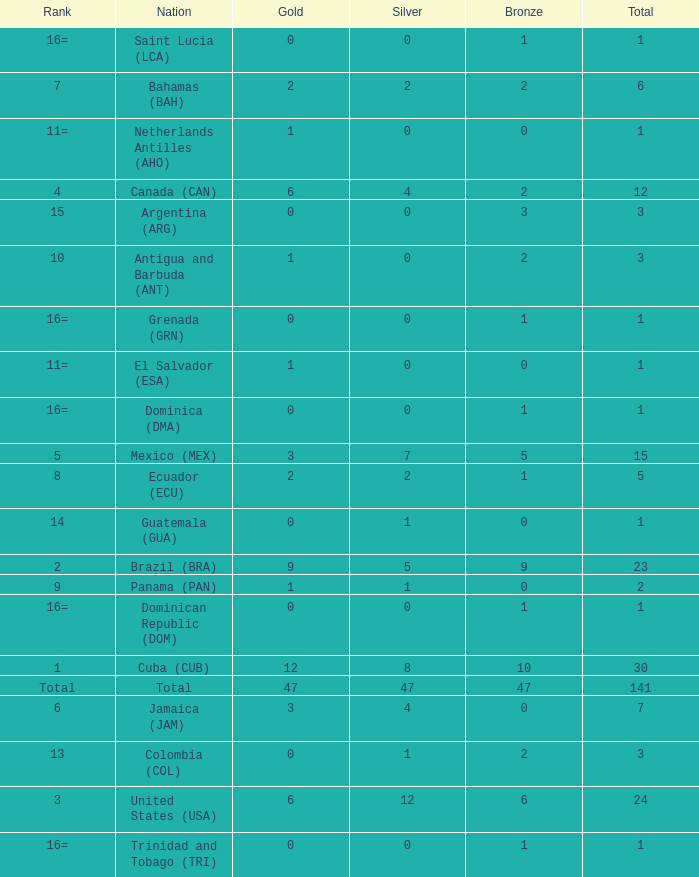What is the total gold with a total less than 1? None. 